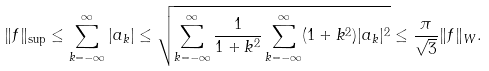<formula> <loc_0><loc_0><loc_500><loc_500>\| f \| _ { \sup } \leq \sum _ { k = - \infty } ^ { \infty } | a _ { k } | \leq \sqrt { \sum _ { k = - \infty } ^ { \infty } \frac { 1 } { 1 + k ^ { 2 } } \sum _ { k = - \infty } ^ { \infty } ( 1 + k ^ { 2 } ) | a _ { k } | ^ { 2 } } \leq \frac { \pi } { \sqrt { 3 } } \| f \| _ { W } .</formula> 